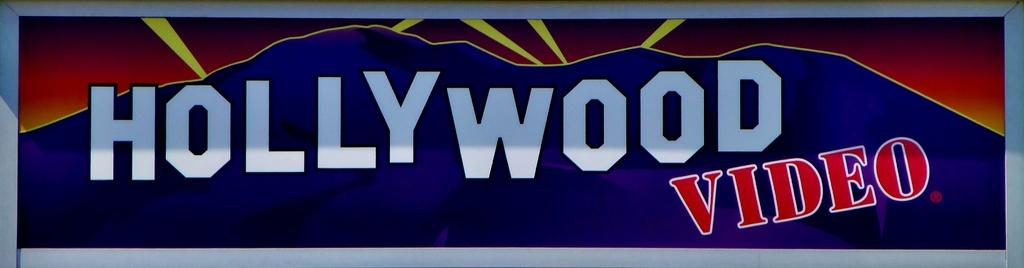<image>
Present a compact description of the photo's key features. An old Hollywood Video banner ad in color. 